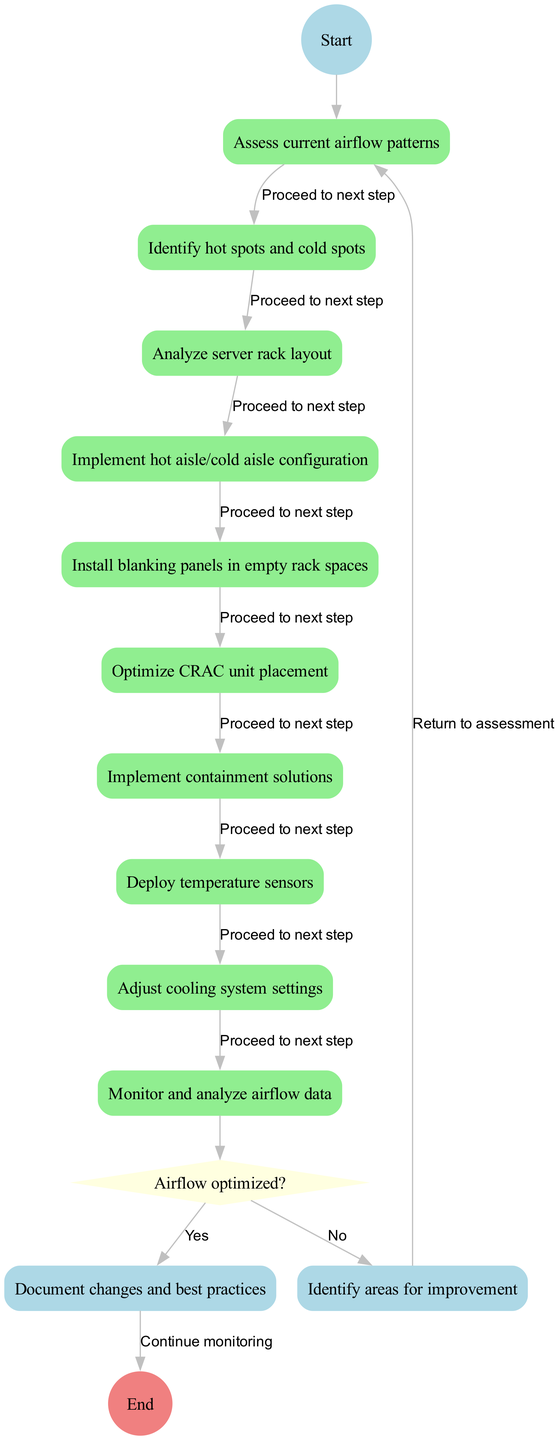What is the first activity in the diagram? The diagram begins with the "Start" node, which leads directly to the first activity labeled "Assess current airflow patterns." Therefore, the first activity that follows is this one.
Answer: Assess current airflow patterns How many activities are listed in the diagram? There are ten activities enumerated in the diagram, which are part of the main flow leading towards the decision node. Counting each listed activity confirms the total.
Answer: Ten What is the condition for the decision node? The decision node in the diagram presents a question regarding whether the airflow has been optimized, therefore, it stipulates this specific condition for the proceeding steps.
Answer: Airflow optimized? What happens if airflow is not optimized? According to the decision pathways shown, if the airflow is not optimized, the next step indicated is to identify areas for improvement, which distinguishes the response based on the condition.
Answer: Identify areas for improvement Which activity follows after implementing containment solutions? Following the activity of implementing containment solutions, the next activity in the flow of the diagram is to deploy temperature sensors, thus maintaining the sequence of actions taken in the optimization process.
Answer: Deploy temperature sensors What links the last activity to the decision node? The last activity before the decision node is "Monitor and analyze airflow data," which is directly connected to the decision node by a single edge in the diagram, indicating the flow of the process.
Answer: Monitor and analyze airflow data What shape is used for the decision node in the diagram? In the rendered diagram, the decision node is represented with a diamond shape, which is a standard symbol for decision points in activity diagrams.
Answer: Diamond 